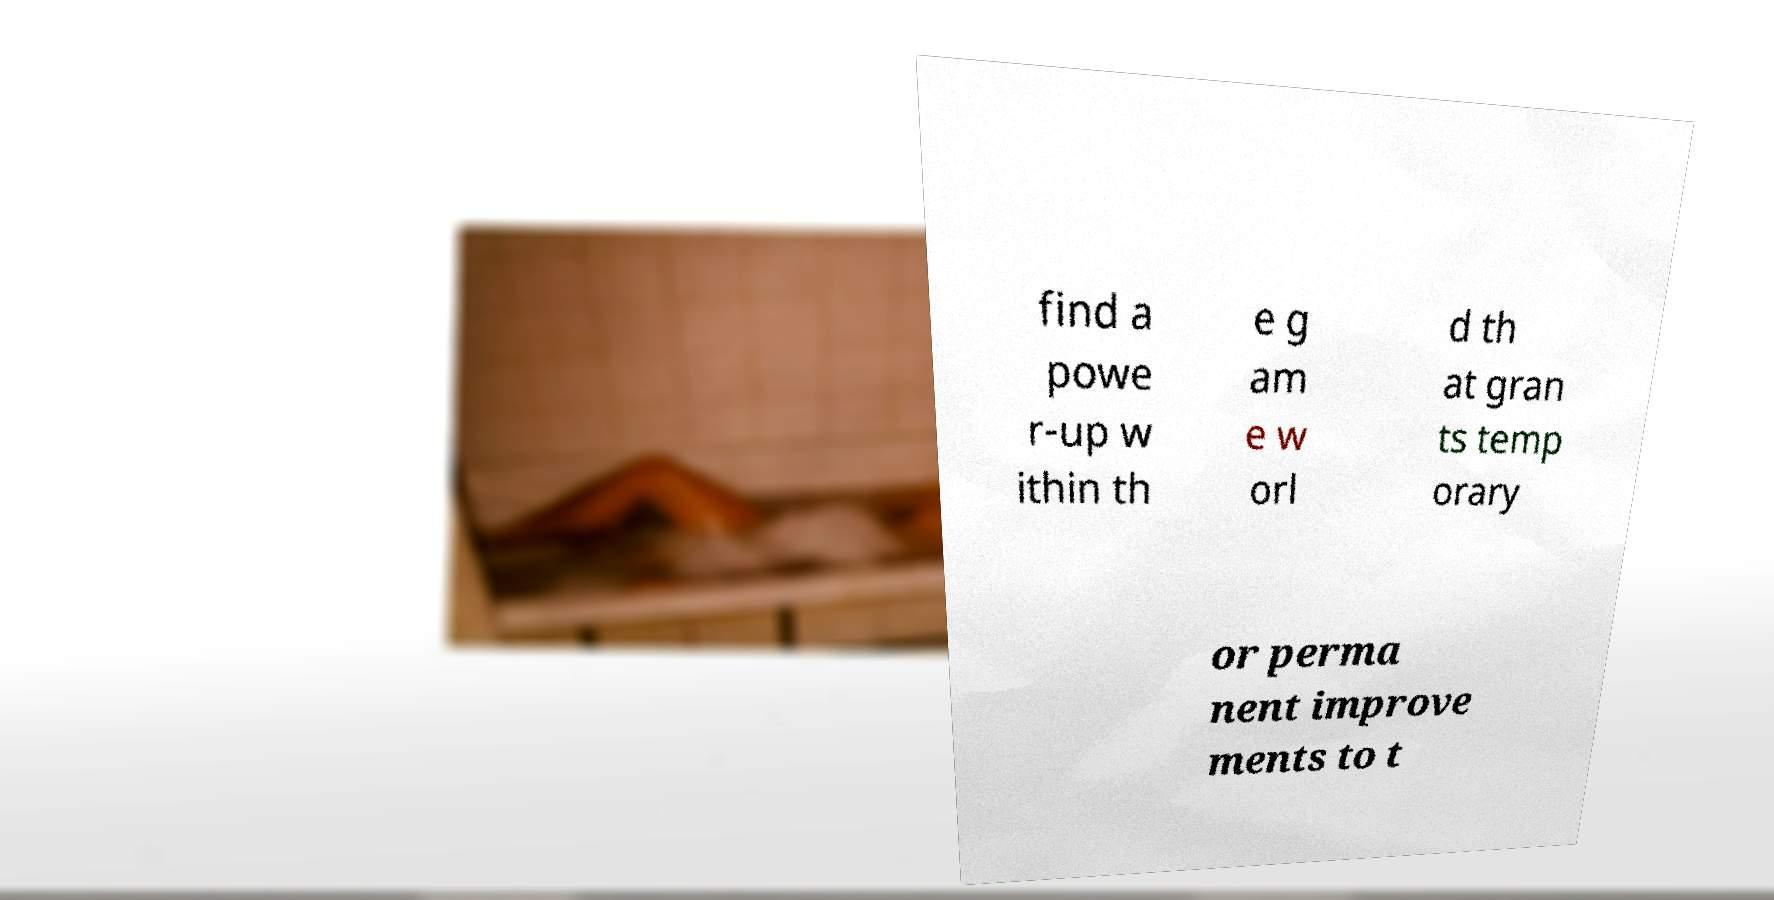Could you extract and type out the text from this image? find a powe r-up w ithin th e g am e w orl d th at gran ts temp orary or perma nent improve ments to t 